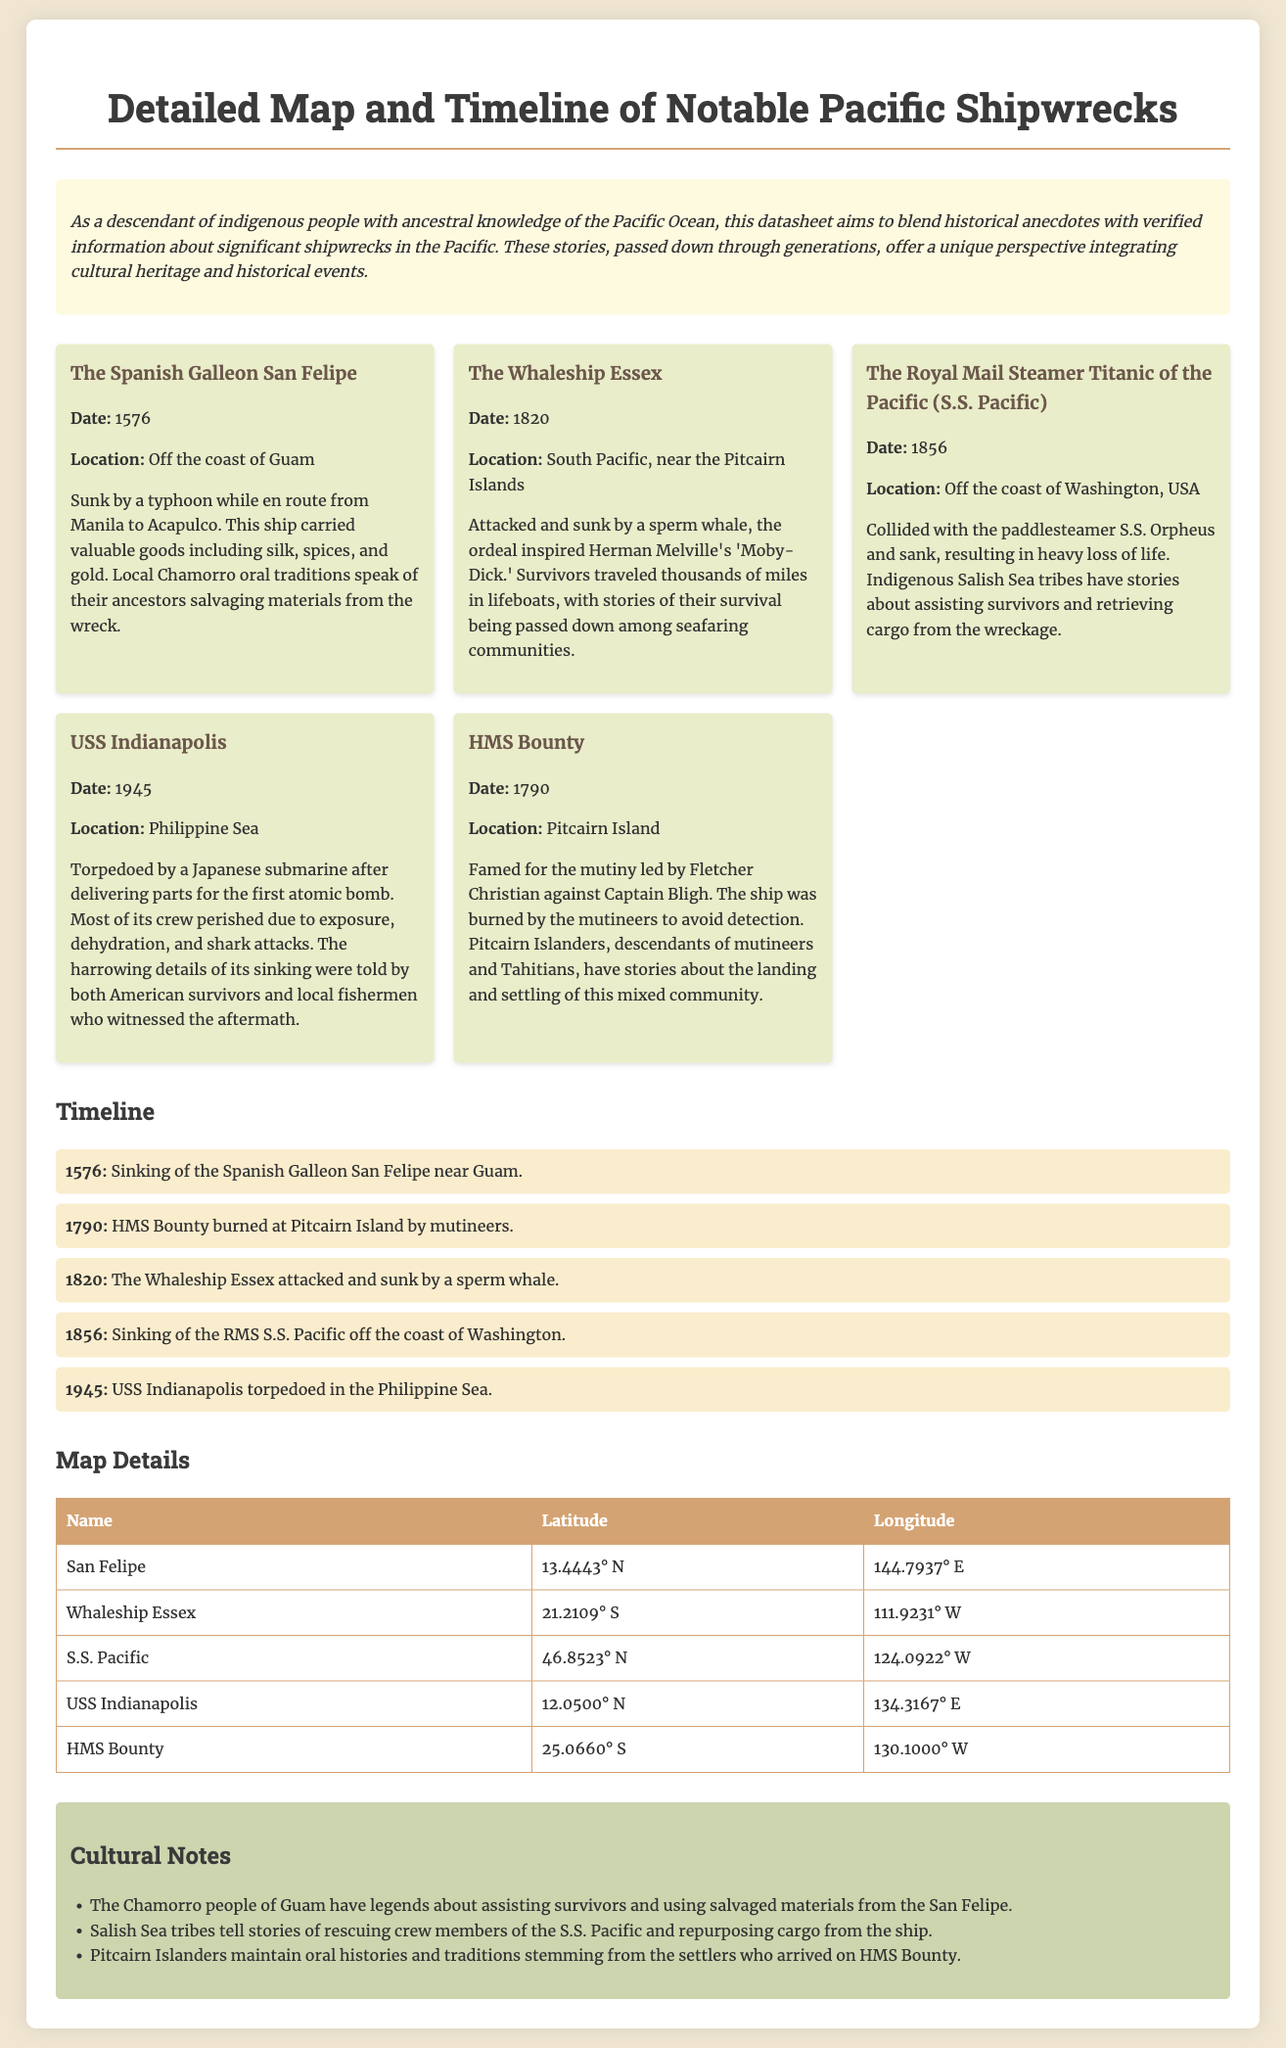what ship sank off the coast of Guam? The document mentions that the Spanish Galleon San Felipe sank off the coast of Guam in 1576.
Answer: Spanish Galleon San Felipe when did the Whaleship Essex sink? The sinking of the Whaleship Essex occurred in 1820, as stated in the timeline section.
Answer: 1820 what was the fate of the USS Indianapolis? The USS Indianapolis was torpedoed by a Japanese submarine after delivering parts for the first atomic bomb, leading to heavy loss of life.
Answer: Torpedoed which indigenous tribe is associated with the shipwreck of S.S. Pacific? The document states that the Indigenous Salish Sea tribes have stories related to the survival of S.S. Pacific.
Answer: Salish Sea tribes what year was the HMS Bounty burned? According to the timeline, the HMS Bounty was burned in the year 1790.
Answer: 1790 who inspired Herman Melville's 'Moby-Dick'? The ordeal of the Whaleship Essex, which was attacked and sunk by a sperm whale, inspired Herman Melville's 'Moby-Dick.'
Answer: Whaleship Essex what do local Chamorro oral traditions speak of? The document notes that local Chamorro oral traditions speak of their ancestors salvaging materials from the wreck of San Felipe.
Answer: Salvaging materials how many notable shipwrecks are listed in the document? The document lists five notable shipwrecks, including the San Felipe, Whaleship Essex, S.S. Pacific, USS Indianapolis, and HMS Bounty.
Answer: Five 